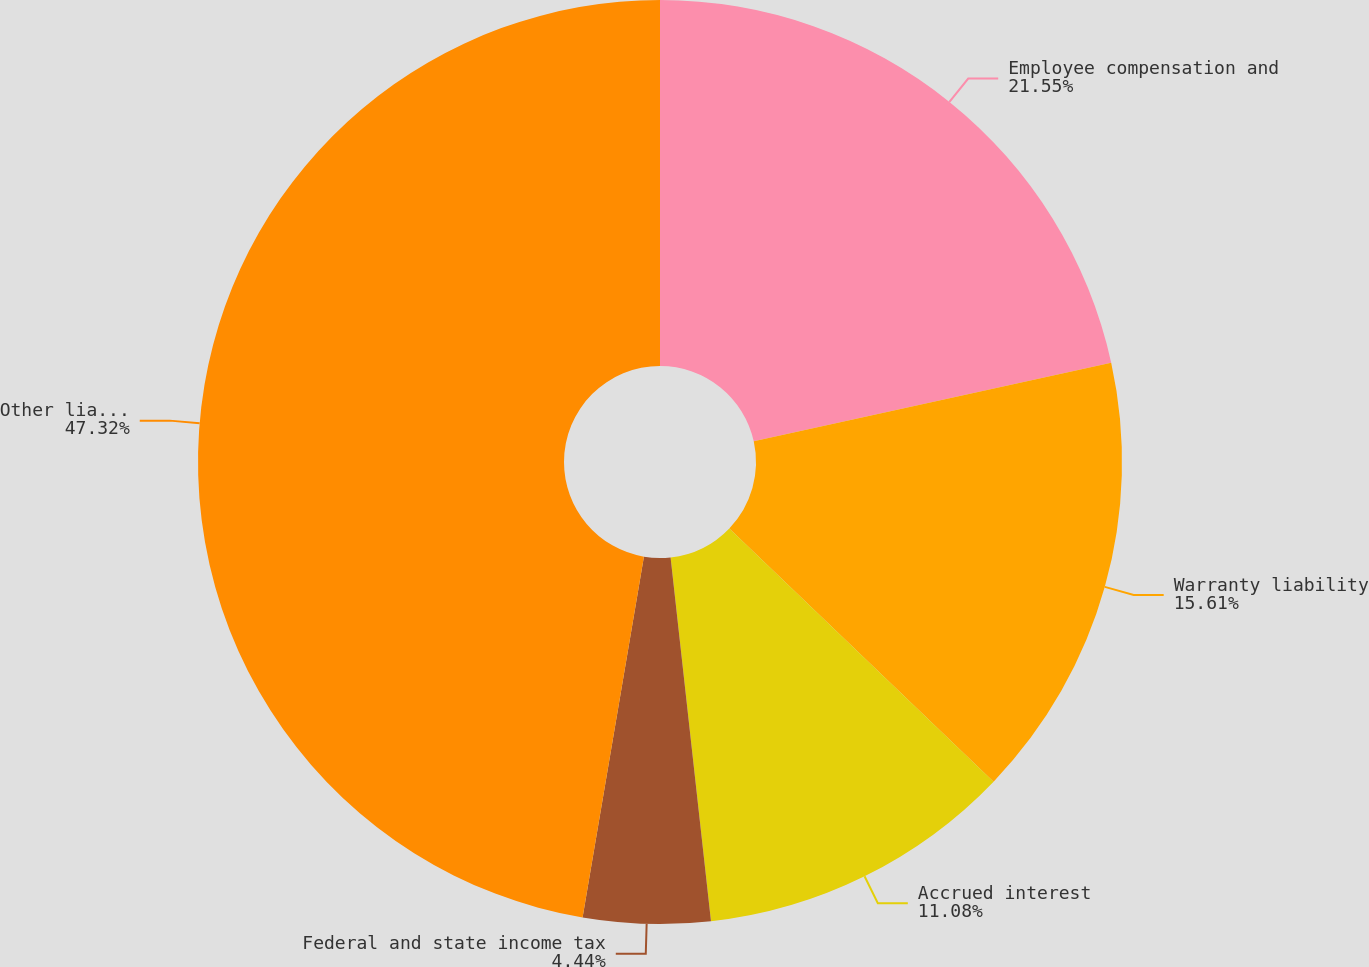<chart> <loc_0><loc_0><loc_500><loc_500><pie_chart><fcel>Employee compensation and<fcel>Warranty liability<fcel>Accrued interest<fcel>Federal and state income tax<fcel>Other liabilities<nl><fcel>21.55%<fcel>15.61%<fcel>11.08%<fcel>4.44%<fcel>47.32%<nl></chart> 